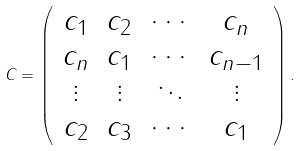Convert formula to latex. <formula><loc_0><loc_0><loc_500><loc_500>C = \left ( \begin{array} { c c c c } c _ { 1 } & c _ { 2 } & \cdots & c _ { n } \\ c _ { n } & c _ { 1 } & \cdots & c _ { n - 1 } \\ \vdots & \vdots & \ddots & \vdots \\ c _ { 2 } & c _ { 3 } & \cdots & c _ { 1 } \\ \end{array} \right ) .</formula> 